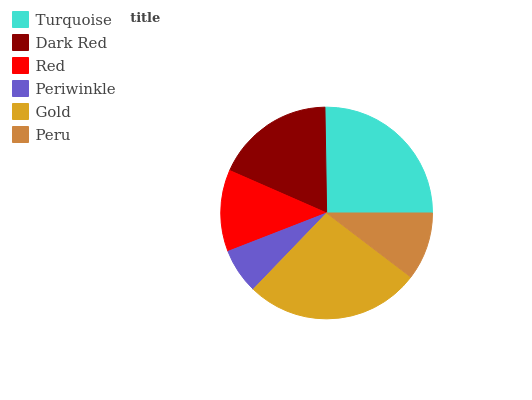Is Periwinkle the minimum?
Answer yes or no. Yes. Is Gold the maximum?
Answer yes or no. Yes. Is Dark Red the minimum?
Answer yes or no. No. Is Dark Red the maximum?
Answer yes or no. No. Is Turquoise greater than Dark Red?
Answer yes or no. Yes. Is Dark Red less than Turquoise?
Answer yes or no. Yes. Is Dark Red greater than Turquoise?
Answer yes or no. No. Is Turquoise less than Dark Red?
Answer yes or no. No. Is Dark Red the high median?
Answer yes or no. Yes. Is Red the low median?
Answer yes or no. Yes. Is Periwinkle the high median?
Answer yes or no. No. Is Turquoise the low median?
Answer yes or no. No. 